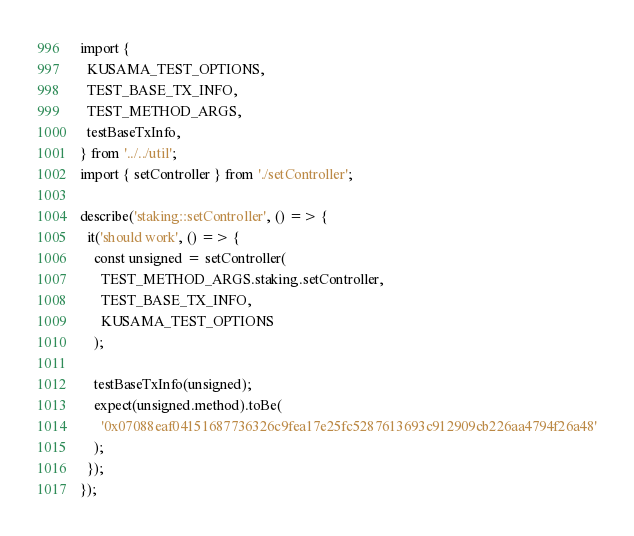<code> <loc_0><loc_0><loc_500><loc_500><_TypeScript_>import {
  KUSAMA_TEST_OPTIONS,
  TEST_BASE_TX_INFO,
  TEST_METHOD_ARGS,
  testBaseTxInfo,
} from '../../util';
import { setController } from './setController';

describe('staking::setController', () => {
  it('should work', () => {
    const unsigned = setController(
      TEST_METHOD_ARGS.staking.setController,
      TEST_BASE_TX_INFO,
      KUSAMA_TEST_OPTIONS
    );

    testBaseTxInfo(unsigned);
    expect(unsigned.method).toBe(
      '0x07088eaf04151687736326c9fea17e25fc5287613693c912909cb226aa4794f26a48'
    );
  });
});
</code> 